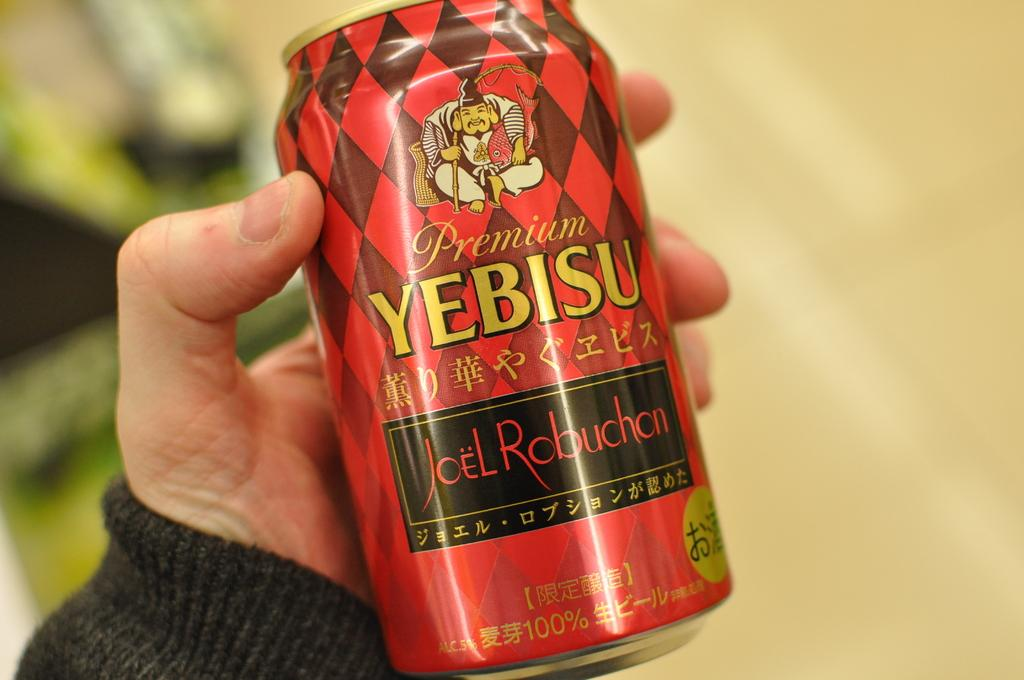<image>
Give a short and clear explanation of the subsequent image. A hand holding a red can of  premium beer. 